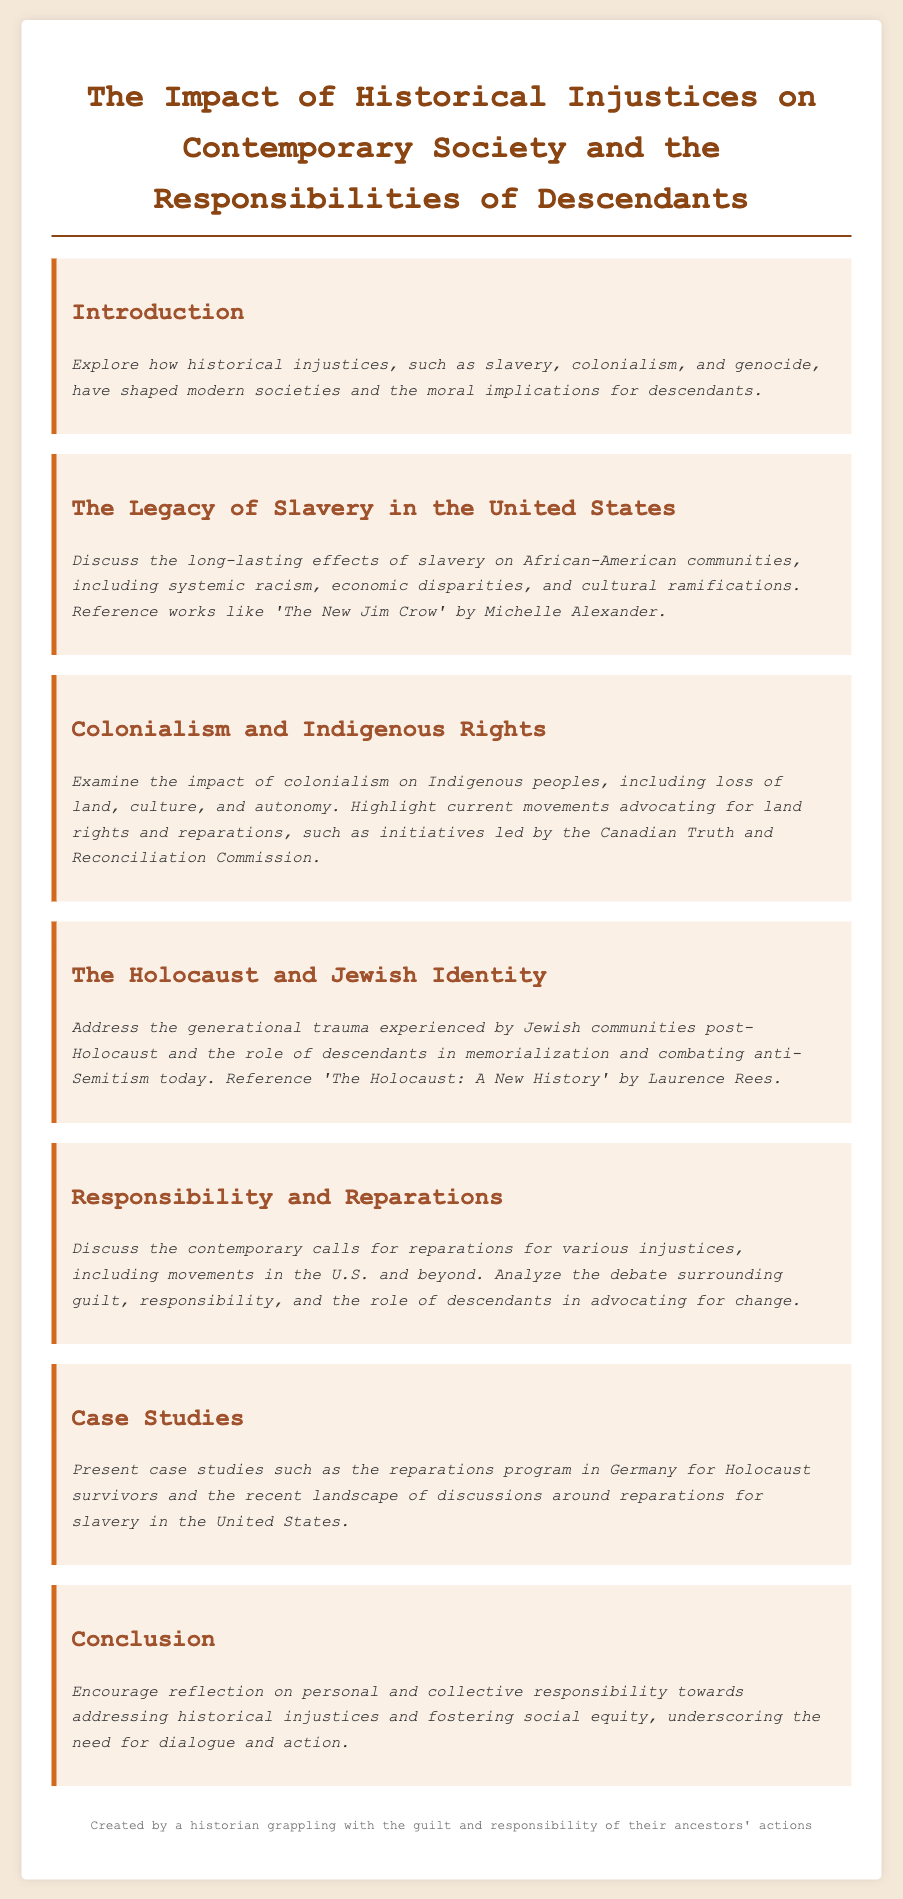What is the primary focus of the document? The document focuses on historical injustices and their impact on contemporary society, as well as the responsibilities of descendants.
Answer: Historical injustices and responsibilities of descendants Which book is referenced regarding the legacy of slavery? The document mentions a specific work that analyzes systemic racism related to slavery, which is "The New Jim Crow."
Answer: "The New Jim Crow" What historical event does the section on Indigenous rights address? The section highlights the impact of colonialism on Indigenous peoples, which is a historical event.
Answer: Colonialism What type of trauma is discussed in relation to Jewish communities? The document details the aftermath experienced by Jewish communities after a significant historical event.
Answer: Generational trauma What initiative is mentioned concerning land rights in Canada? The document specifies a commission that advocates for Indigenous rights in Canada.
Answer: Canadian Truth and Reconciliation Commission What theme is explored in the section on reparations? The document discusses the various calls for reparations linked to historical injustices and the role of descendants.
Answer: Calls for reparations Which country has a reparations program for Holocaust survivors? The document identifies a specific nation known for its reparations program linked to a historical atrocity.
Answer: Germany What is the outcome hoped for in the conclusion? The conclusion encourages a specific attitude among readers about addressing injustices.
Answer: Reflection on responsibility 